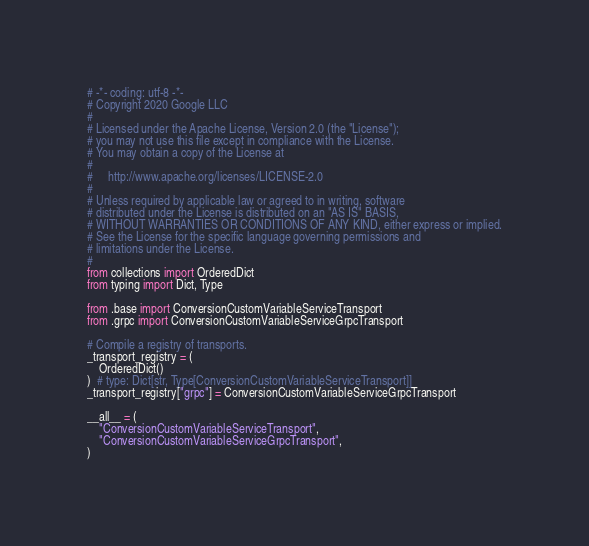Convert code to text. <code><loc_0><loc_0><loc_500><loc_500><_Python_># -*- coding: utf-8 -*-
# Copyright 2020 Google LLC
#
# Licensed under the Apache License, Version 2.0 (the "License");
# you may not use this file except in compliance with the License.
# You may obtain a copy of the License at
#
#     http://www.apache.org/licenses/LICENSE-2.0
#
# Unless required by applicable law or agreed to in writing, software
# distributed under the License is distributed on an "AS IS" BASIS,
# WITHOUT WARRANTIES OR CONDITIONS OF ANY KIND, either express or implied.
# See the License for the specific language governing permissions and
# limitations under the License.
#
from collections import OrderedDict
from typing import Dict, Type

from .base import ConversionCustomVariableServiceTransport
from .grpc import ConversionCustomVariableServiceGrpcTransport

# Compile a registry of transports.
_transport_registry = (
    OrderedDict()
)  # type: Dict[str, Type[ConversionCustomVariableServiceTransport]]
_transport_registry["grpc"] = ConversionCustomVariableServiceGrpcTransport

__all__ = (
    "ConversionCustomVariableServiceTransport",
    "ConversionCustomVariableServiceGrpcTransport",
)
</code> 